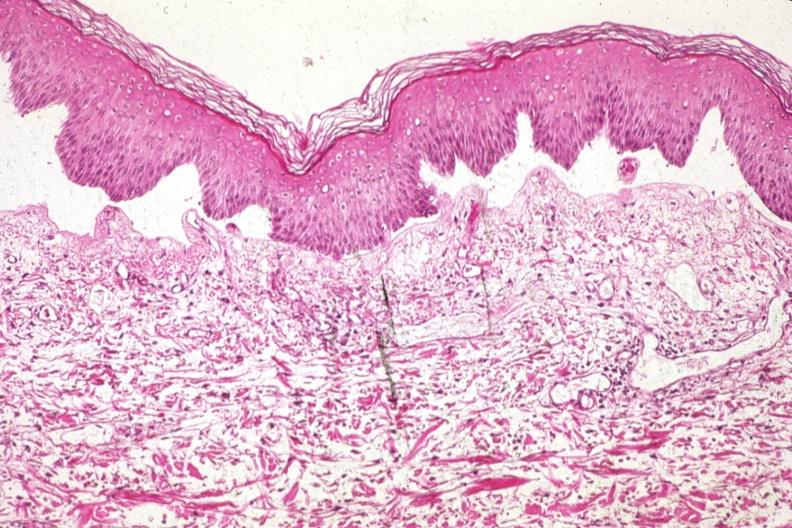s med excellent example of epidermal separation gross of this lesion 907?
Answer the question using a single word or phrase. Yes 